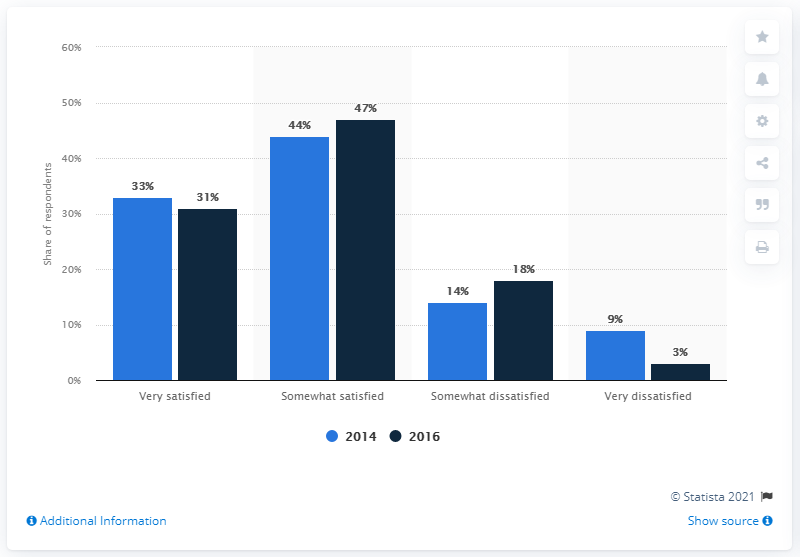Indicate a few pertinent items in this graphic. The average of the navy blue bars is 24.75. The opinion that underwent the most significant change between 2014 and 2016 was that of those who were somewhat dissatisfied with the job market. 